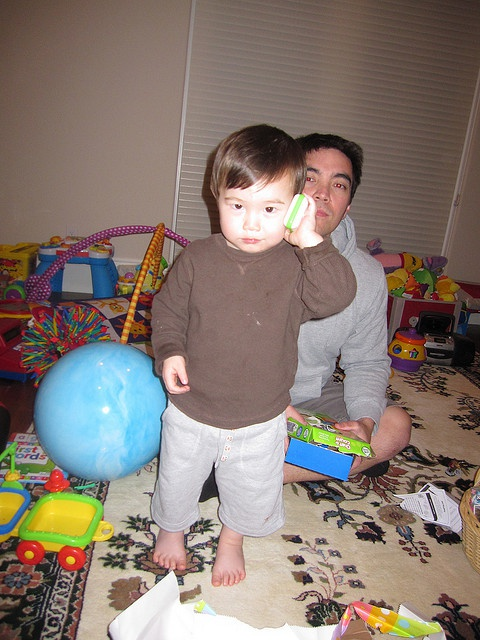Describe the objects in this image and their specific colors. I can see bed in black, darkgray, and gray tones, people in black, gray, lightgray, and lightpink tones, people in black, darkgray, brown, and gray tones, sports ball in black, lightblue, and gray tones, and cell phone in black, white, and lightgreen tones in this image. 